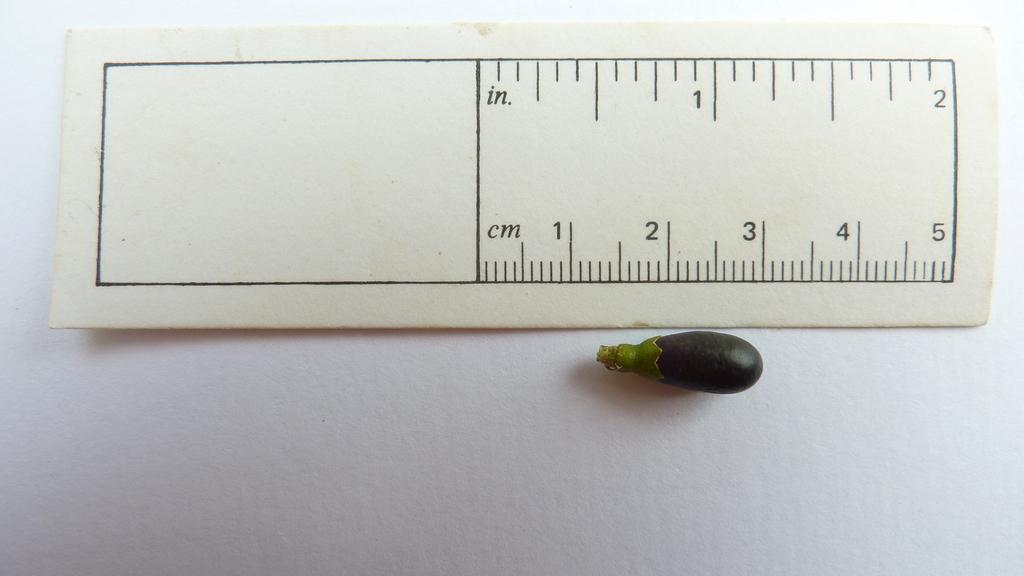How long is the object?
Give a very brief answer. 2cm. How long is it?
Your answer should be compact. 2 cm. 